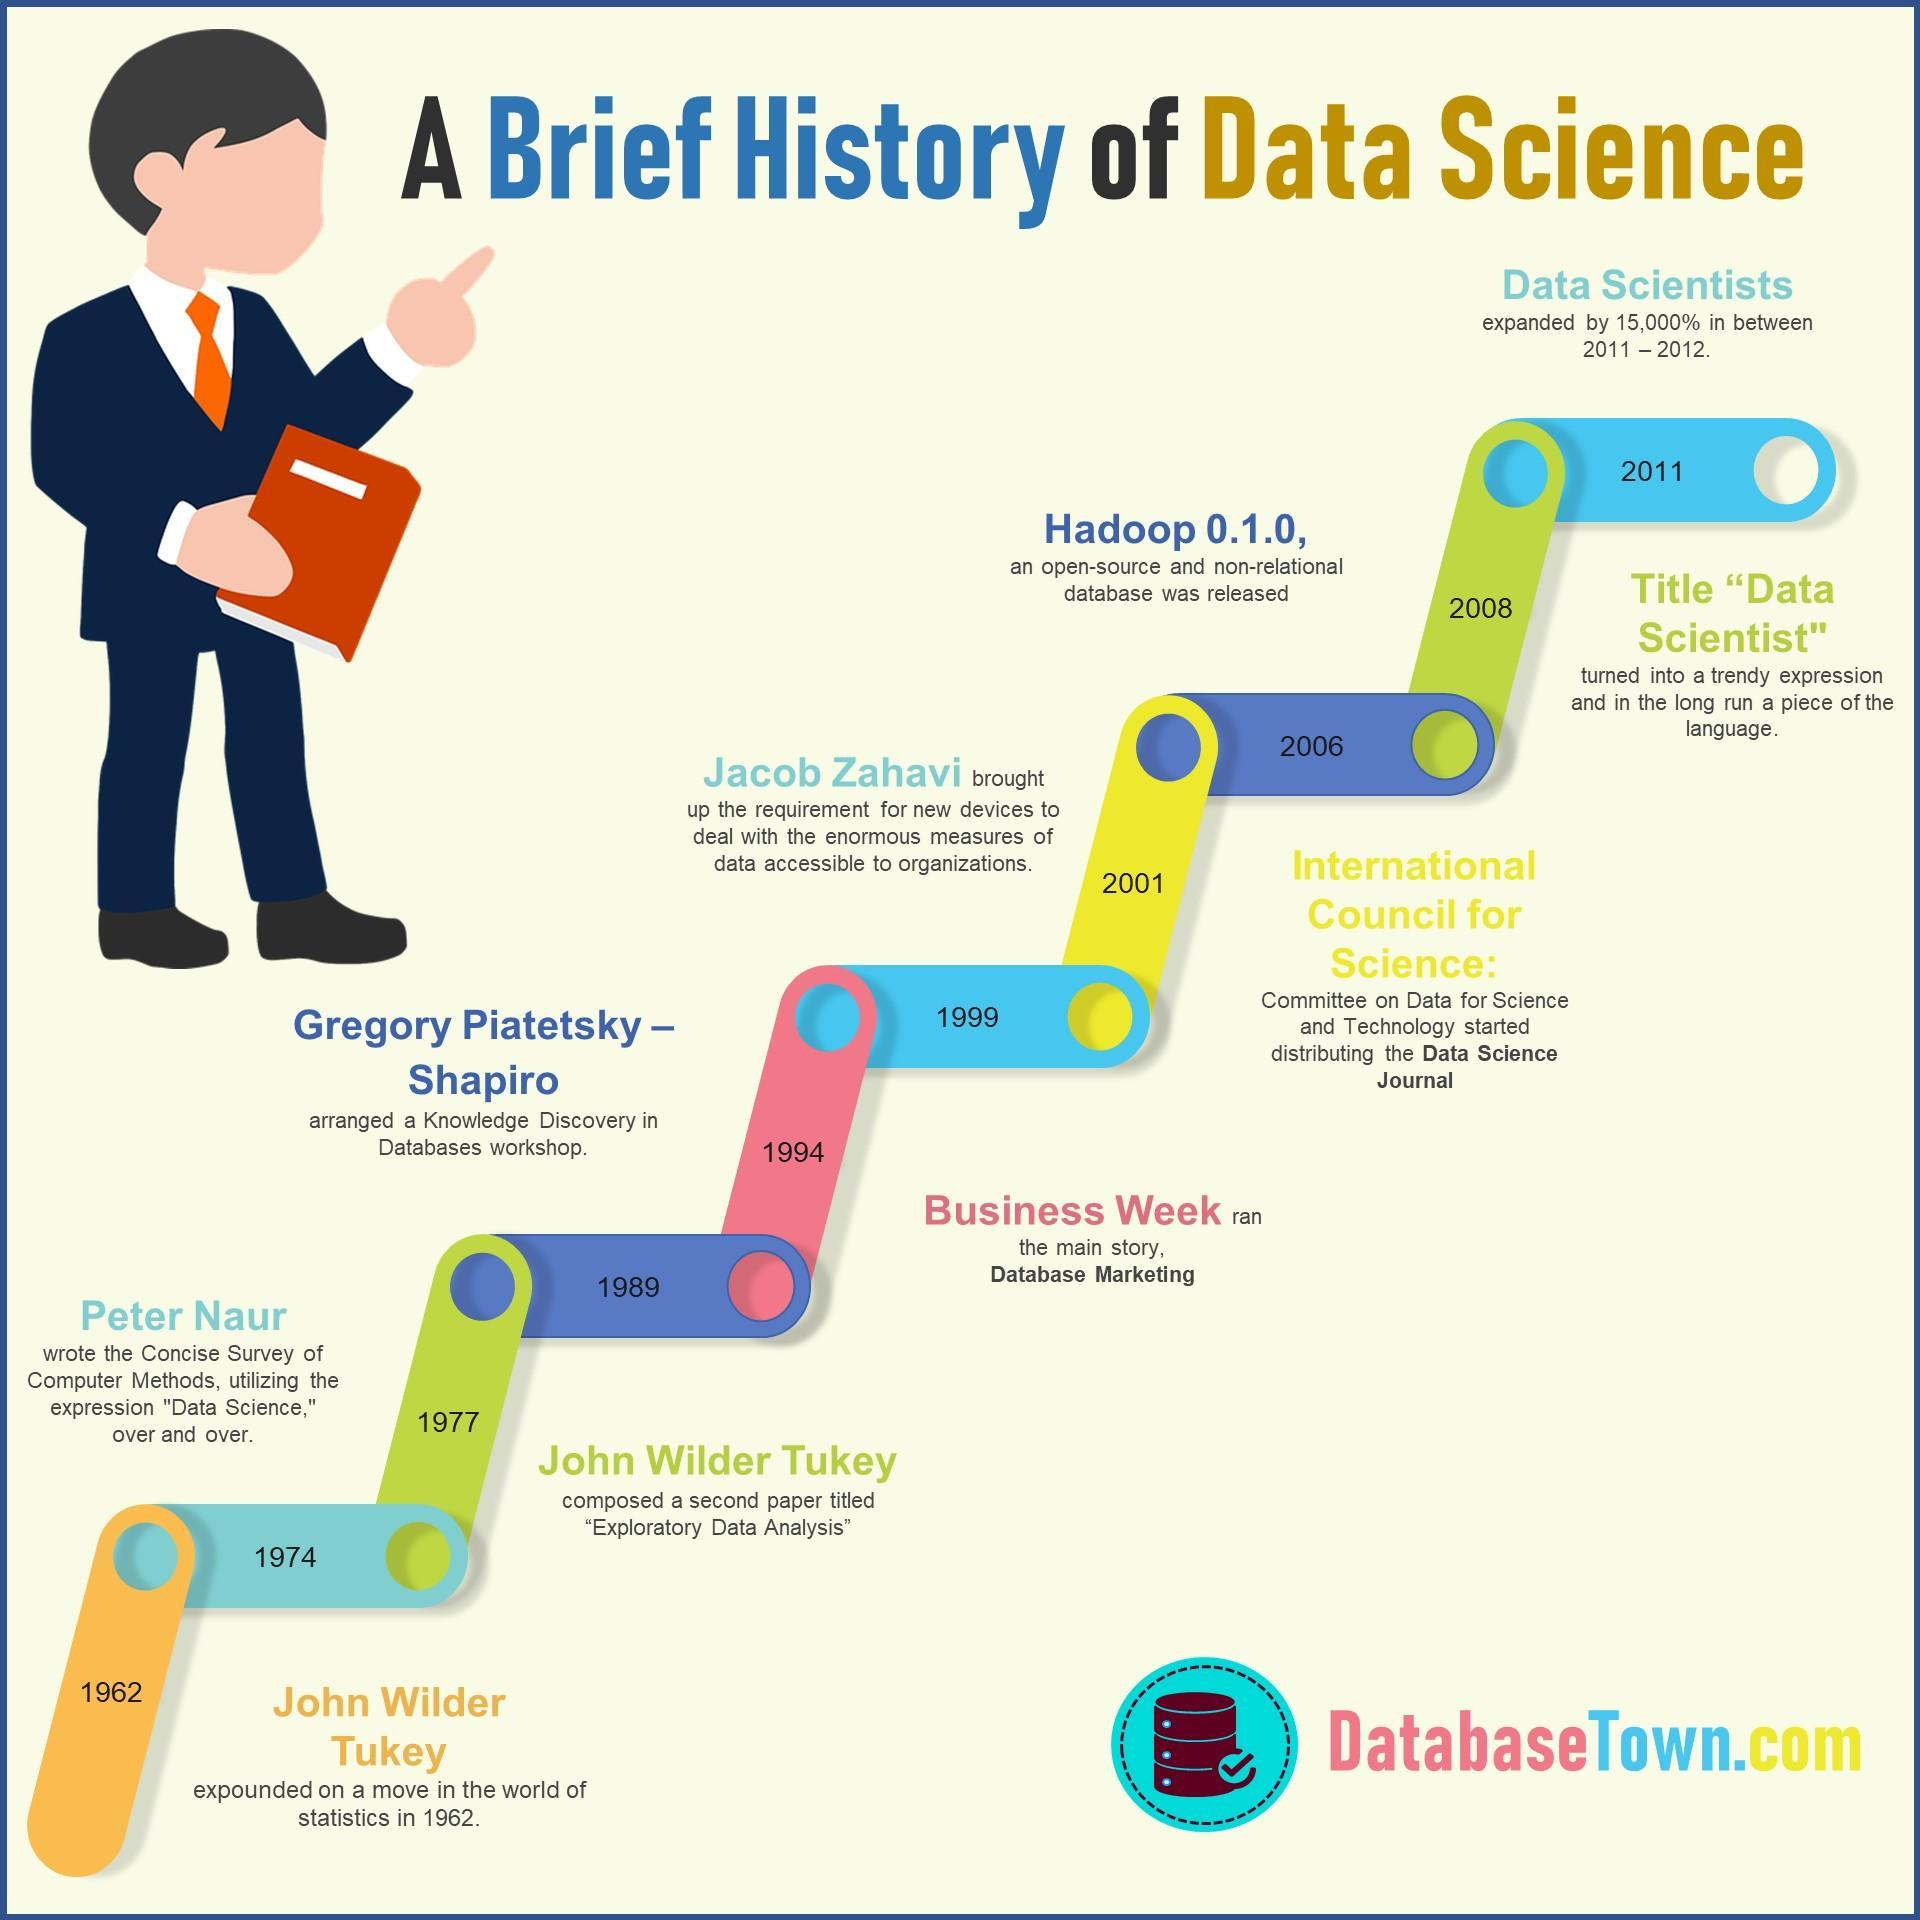In which year Peter Naur wrote the concise survey of computer methods?
Answer the question with a short phrase. 1974 In which year Hadoop 0.1.0 released? 2006 In which year Gregory Piatetsky-Shapiro arranged a knowledge discovery in the databases workshop? 1989 